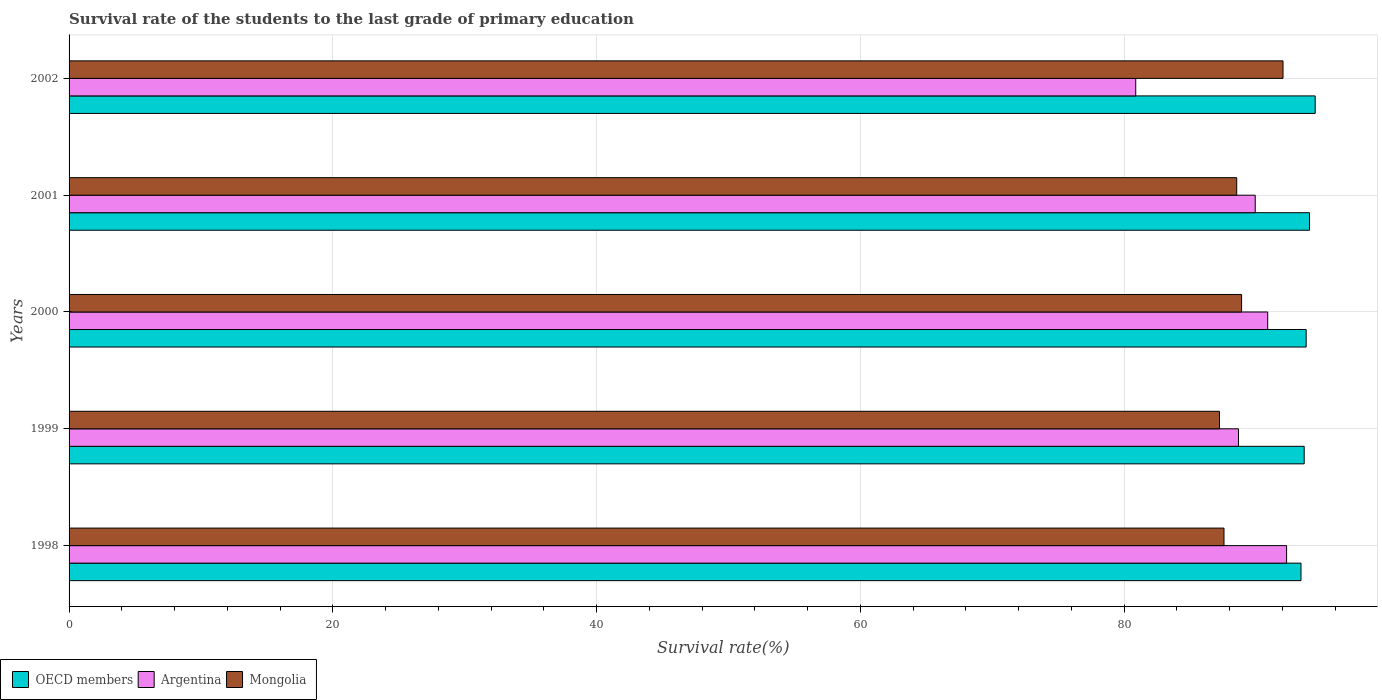Are the number of bars per tick equal to the number of legend labels?
Offer a very short reply. Yes. What is the label of the 3rd group of bars from the top?
Provide a short and direct response. 2000. What is the survival rate of the students in Mongolia in 2000?
Your answer should be very brief. 88.9. Across all years, what is the maximum survival rate of the students in Mongolia?
Offer a very short reply. 92.04. Across all years, what is the minimum survival rate of the students in Mongolia?
Your answer should be very brief. 87.22. What is the total survival rate of the students in Mongolia in the graph?
Offer a very short reply. 444.25. What is the difference between the survival rate of the students in Mongolia in 1998 and that in 2000?
Your response must be concise. -1.33. What is the difference between the survival rate of the students in Mongolia in 2000 and the survival rate of the students in Argentina in 2002?
Offer a terse response. 8.03. What is the average survival rate of the students in OECD members per year?
Your answer should be compact. 93.87. In the year 2001, what is the difference between the survival rate of the students in OECD members and survival rate of the students in Argentina?
Give a very brief answer. 4.12. What is the ratio of the survival rate of the students in Mongolia in 1998 to that in 2002?
Make the answer very short. 0.95. Is the survival rate of the students in Mongolia in 2000 less than that in 2001?
Keep it short and to the point. No. What is the difference between the highest and the second highest survival rate of the students in OECD members?
Provide a short and direct response. 0.43. What is the difference between the highest and the lowest survival rate of the students in Mongolia?
Your answer should be compact. 4.82. In how many years, is the survival rate of the students in Mongolia greater than the average survival rate of the students in Mongolia taken over all years?
Ensure brevity in your answer.  2. What does the 3rd bar from the top in 1998 represents?
Give a very brief answer. OECD members. What does the 3rd bar from the bottom in 1999 represents?
Your response must be concise. Mongolia. Is it the case that in every year, the sum of the survival rate of the students in Mongolia and survival rate of the students in Argentina is greater than the survival rate of the students in OECD members?
Your answer should be very brief. Yes. How many years are there in the graph?
Offer a very short reply. 5. What is the difference between two consecutive major ticks on the X-axis?
Keep it short and to the point. 20. Where does the legend appear in the graph?
Your answer should be compact. Bottom left. How many legend labels are there?
Provide a succinct answer. 3. How are the legend labels stacked?
Your answer should be very brief. Horizontal. What is the title of the graph?
Give a very brief answer. Survival rate of the students to the last grade of primary education. What is the label or title of the X-axis?
Make the answer very short. Survival rate(%). What is the Survival rate(%) in OECD members in 1998?
Give a very brief answer. 93.4. What is the Survival rate(%) in Argentina in 1998?
Ensure brevity in your answer.  92.31. What is the Survival rate(%) in Mongolia in 1998?
Offer a terse response. 87.56. What is the Survival rate(%) in OECD members in 1999?
Give a very brief answer. 93.64. What is the Survival rate(%) in Argentina in 1999?
Keep it short and to the point. 88.66. What is the Survival rate(%) of Mongolia in 1999?
Give a very brief answer. 87.22. What is the Survival rate(%) of OECD members in 2000?
Provide a succinct answer. 93.79. What is the Survival rate(%) of Argentina in 2000?
Offer a very short reply. 90.88. What is the Survival rate(%) of Mongolia in 2000?
Make the answer very short. 88.9. What is the Survival rate(%) in OECD members in 2001?
Give a very brief answer. 94.05. What is the Survival rate(%) in Argentina in 2001?
Offer a very short reply. 89.93. What is the Survival rate(%) in Mongolia in 2001?
Make the answer very short. 88.53. What is the Survival rate(%) in OECD members in 2002?
Make the answer very short. 94.48. What is the Survival rate(%) in Argentina in 2002?
Your answer should be very brief. 80.87. What is the Survival rate(%) in Mongolia in 2002?
Ensure brevity in your answer.  92.04. Across all years, what is the maximum Survival rate(%) in OECD members?
Your answer should be very brief. 94.48. Across all years, what is the maximum Survival rate(%) in Argentina?
Offer a terse response. 92.31. Across all years, what is the maximum Survival rate(%) of Mongolia?
Your response must be concise. 92.04. Across all years, what is the minimum Survival rate(%) of OECD members?
Your answer should be compact. 93.4. Across all years, what is the minimum Survival rate(%) in Argentina?
Give a very brief answer. 80.87. Across all years, what is the minimum Survival rate(%) of Mongolia?
Offer a terse response. 87.22. What is the total Survival rate(%) of OECD members in the graph?
Your response must be concise. 469.37. What is the total Survival rate(%) of Argentina in the graph?
Your response must be concise. 442.66. What is the total Survival rate(%) of Mongolia in the graph?
Offer a very short reply. 444.25. What is the difference between the Survival rate(%) in OECD members in 1998 and that in 1999?
Provide a short and direct response. -0.24. What is the difference between the Survival rate(%) of Argentina in 1998 and that in 1999?
Your answer should be very brief. 3.65. What is the difference between the Survival rate(%) of Mongolia in 1998 and that in 1999?
Your answer should be very brief. 0.34. What is the difference between the Survival rate(%) of OECD members in 1998 and that in 2000?
Your response must be concise. -0.39. What is the difference between the Survival rate(%) in Argentina in 1998 and that in 2000?
Ensure brevity in your answer.  1.43. What is the difference between the Survival rate(%) of Mongolia in 1998 and that in 2000?
Give a very brief answer. -1.33. What is the difference between the Survival rate(%) in OECD members in 1998 and that in 2001?
Provide a succinct answer. -0.65. What is the difference between the Survival rate(%) in Argentina in 1998 and that in 2001?
Offer a very short reply. 2.38. What is the difference between the Survival rate(%) of Mongolia in 1998 and that in 2001?
Provide a succinct answer. -0.96. What is the difference between the Survival rate(%) of OECD members in 1998 and that in 2002?
Offer a terse response. -1.08. What is the difference between the Survival rate(%) in Argentina in 1998 and that in 2002?
Your response must be concise. 11.44. What is the difference between the Survival rate(%) in Mongolia in 1998 and that in 2002?
Ensure brevity in your answer.  -4.47. What is the difference between the Survival rate(%) in OECD members in 1999 and that in 2000?
Offer a terse response. -0.15. What is the difference between the Survival rate(%) in Argentina in 1999 and that in 2000?
Ensure brevity in your answer.  -2.21. What is the difference between the Survival rate(%) of Mongolia in 1999 and that in 2000?
Provide a short and direct response. -1.68. What is the difference between the Survival rate(%) in OECD members in 1999 and that in 2001?
Offer a terse response. -0.4. What is the difference between the Survival rate(%) in Argentina in 1999 and that in 2001?
Give a very brief answer. -1.27. What is the difference between the Survival rate(%) of Mongolia in 1999 and that in 2001?
Offer a terse response. -1.31. What is the difference between the Survival rate(%) in OECD members in 1999 and that in 2002?
Your answer should be compact. -0.83. What is the difference between the Survival rate(%) in Argentina in 1999 and that in 2002?
Ensure brevity in your answer.  7.79. What is the difference between the Survival rate(%) in Mongolia in 1999 and that in 2002?
Your answer should be compact. -4.82. What is the difference between the Survival rate(%) of OECD members in 2000 and that in 2001?
Your answer should be very brief. -0.25. What is the difference between the Survival rate(%) in Argentina in 2000 and that in 2001?
Provide a short and direct response. 0.95. What is the difference between the Survival rate(%) in Mongolia in 2000 and that in 2001?
Give a very brief answer. 0.37. What is the difference between the Survival rate(%) of OECD members in 2000 and that in 2002?
Your response must be concise. -0.68. What is the difference between the Survival rate(%) of Argentina in 2000 and that in 2002?
Your answer should be very brief. 10.01. What is the difference between the Survival rate(%) of Mongolia in 2000 and that in 2002?
Your response must be concise. -3.14. What is the difference between the Survival rate(%) of OECD members in 2001 and that in 2002?
Ensure brevity in your answer.  -0.43. What is the difference between the Survival rate(%) in Argentina in 2001 and that in 2002?
Provide a short and direct response. 9.06. What is the difference between the Survival rate(%) in Mongolia in 2001 and that in 2002?
Your response must be concise. -3.51. What is the difference between the Survival rate(%) in OECD members in 1998 and the Survival rate(%) in Argentina in 1999?
Keep it short and to the point. 4.74. What is the difference between the Survival rate(%) in OECD members in 1998 and the Survival rate(%) in Mongolia in 1999?
Offer a terse response. 6.18. What is the difference between the Survival rate(%) in Argentina in 1998 and the Survival rate(%) in Mongolia in 1999?
Make the answer very short. 5.09. What is the difference between the Survival rate(%) of OECD members in 1998 and the Survival rate(%) of Argentina in 2000?
Your answer should be very brief. 2.52. What is the difference between the Survival rate(%) of OECD members in 1998 and the Survival rate(%) of Mongolia in 2000?
Provide a succinct answer. 4.5. What is the difference between the Survival rate(%) of Argentina in 1998 and the Survival rate(%) of Mongolia in 2000?
Offer a very short reply. 3.41. What is the difference between the Survival rate(%) in OECD members in 1998 and the Survival rate(%) in Argentina in 2001?
Make the answer very short. 3.47. What is the difference between the Survival rate(%) of OECD members in 1998 and the Survival rate(%) of Mongolia in 2001?
Ensure brevity in your answer.  4.87. What is the difference between the Survival rate(%) of Argentina in 1998 and the Survival rate(%) of Mongolia in 2001?
Provide a short and direct response. 3.78. What is the difference between the Survival rate(%) of OECD members in 1998 and the Survival rate(%) of Argentina in 2002?
Your response must be concise. 12.53. What is the difference between the Survival rate(%) of OECD members in 1998 and the Survival rate(%) of Mongolia in 2002?
Offer a terse response. 1.36. What is the difference between the Survival rate(%) in Argentina in 1998 and the Survival rate(%) in Mongolia in 2002?
Provide a succinct answer. 0.27. What is the difference between the Survival rate(%) of OECD members in 1999 and the Survival rate(%) of Argentina in 2000?
Provide a short and direct response. 2.77. What is the difference between the Survival rate(%) of OECD members in 1999 and the Survival rate(%) of Mongolia in 2000?
Keep it short and to the point. 4.75. What is the difference between the Survival rate(%) of Argentina in 1999 and the Survival rate(%) of Mongolia in 2000?
Provide a short and direct response. -0.23. What is the difference between the Survival rate(%) of OECD members in 1999 and the Survival rate(%) of Argentina in 2001?
Your response must be concise. 3.71. What is the difference between the Survival rate(%) in OECD members in 1999 and the Survival rate(%) in Mongolia in 2001?
Give a very brief answer. 5.12. What is the difference between the Survival rate(%) of Argentina in 1999 and the Survival rate(%) of Mongolia in 2001?
Provide a short and direct response. 0.14. What is the difference between the Survival rate(%) in OECD members in 1999 and the Survival rate(%) in Argentina in 2002?
Ensure brevity in your answer.  12.77. What is the difference between the Survival rate(%) in OECD members in 1999 and the Survival rate(%) in Mongolia in 2002?
Make the answer very short. 1.61. What is the difference between the Survival rate(%) in Argentina in 1999 and the Survival rate(%) in Mongolia in 2002?
Make the answer very short. -3.37. What is the difference between the Survival rate(%) in OECD members in 2000 and the Survival rate(%) in Argentina in 2001?
Keep it short and to the point. 3.86. What is the difference between the Survival rate(%) in OECD members in 2000 and the Survival rate(%) in Mongolia in 2001?
Make the answer very short. 5.27. What is the difference between the Survival rate(%) of Argentina in 2000 and the Survival rate(%) of Mongolia in 2001?
Give a very brief answer. 2.35. What is the difference between the Survival rate(%) of OECD members in 2000 and the Survival rate(%) of Argentina in 2002?
Give a very brief answer. 12.92. What is the difference between the Survival rate(%) of OECD members in 2000 and the Survival rate(%) of Mongolia in 2002?
Give a very brief answer. 1.76. What is the difference between the Survival rate(%) of Argentina in 2000 and the Survival rate(%) of Mongolia in 2002?
Your answer should be very brief. -1.16. What is the difference between the Survival rate(%) of OECD members in 2001 and the Survival rate(%) of Argentina in 2002?
Ensure brevity in your answer.  13.18. What is the difference between the Survival rate(%) in OECD members in 2001 and the Survival rate(%) in Mongolia in 2002?
Give a very brief answer. 2.01. What is the difference between the Survival rate(%) of Argentina in 2001 and the Survival rate(%) of Mongolia in 2002?
Your answer should be compact. -2.11. What is the average Survival rate(%) of OECD members per year?
Keep it short and to the point. 93.87. What is the average Survival rate(%) in Argentina per year?
Give a very brief answer. 88.53. What is the average Survival rate(%) of Mongolia per year?
Keep it short and to the point. 88.85. In the year 1998, what is the difference between the Survival rate(%) in OECD members and Survival rate(%) in Argentina?
Your answer should be compact. 1.09. In the year 1998, what is the difference between the Survival rate(%) in OECD members and Survival rate(%) in Mongolia?
Ensure brevity in your answer.  5.84. In the year 1998, what is the difference between the Survival rate(%) in Argentina and Survival rate(%) in Mongolia?
Your response must be concise. 4.75. In the year 1999, what is the difference between the Survival rate(%) in OECD members and Survival rate(%) in Argentina?
Make the answer very short. 4.98. In the year 1999, what is the difference between the Survival rate(%) of OECD members and Survival rate(%) of Mongolia?
Ensure brevity in your answer.  6.42. In the year 1999, what is the difference between the Survival rate(%) of Argentina and Survival rate(%) of Mongolia?
Provide a succinct answer. 1.44. In the year 2000, what is the difference between the Survival rate(%) of OECD members and Survival rate(%) of Argentina?
Provide a succinct answer. 2.92. In the year 2000, what is the difference between the Survival rate(%) of OECD members and Survival rate(%) of Mongolia?
Keep it short and to the point. 4.9. In the year 2000, what is the difference between the Survival rate(%) in Argentina and Survival rate(%) in Mongolia?
Offer a terse response. 1.98. In the year 2001, what is the difference between the Survival rate(%) in OECD members and Survival rate(%) in Argentina?
Offer a very short reply. 4.12. In the year 2001, what is the difference between the Survival rate(%) in OECD members and Survival rate(%) in Mongolia?
Provide a succinct answer. 5.52. In the year 2001, what is the difference between the Survival rate(%) in Argentina and Survival rate(%) in Mongolia?
Your answer should be very brief. 1.4. In the year 2002, what is the difference between the Survival rate(%) in OECD members and Survival rate(%) in Argentina?
Your answer should be very brief. 13.61. In the year 2002, what is the difference between the Survival rate(%) in OECD members and Survival rate(%) in Mongolia?
Ensure brevity in your answer.  2.44. In the year 2002, what is the difference between the Survival rate(%) of Argentina and Survival rate(%) of Mongolia?
Provide a succinct answer. -11.17. What is the ratio of the Survival rate(%) of Argentina in 1998 to that in 1999?
Your response must be concise. 1.04. What is the ratio of the Survival rate(%) in OECD members in 1998 to that in 2000?
Ensure brevity in your answer.  1. What is the ratio of the Survival rate(%) of Argentina in 1998 to that in 2000?
Your answer should be compact. 1.02. What is the ratio of the Survival rate(%) in Argentina in 1998 to that in 2001?
Give a very brief answer. 1.03. What is the ratio of the Survival rate(%) in OECD members in 1998 to that in 2002?
Your answer should be very brief. 0.99. What is the ratio of the Survival rate(%) of Argentina in 1998 to that in 2002?
Keep it short and to the point. 1.14. What is the ratio of the Survival rate(%) in Mongolia in 1998 to that in 2002?
Your answer should be compact. 0.95. What is the ratio of the Survival rate(%) of OECD members in 1999 to that in 2000?
Provide a short and direct response. 1. What is the ratio of the Survival rate(%) of Argentina in 1999 to that in 2000?
Make the answer very short. 0.98. What is the ratio of the Survival rate(%) of Mongolia in 1999 to that in 2000?
Your answer should be very brief. 0.98. What is the ratio of the Survival rate(%) of OECD members in 1999 to that in 2001?
Provide a short and direct response. 1. What is the ratio of the Survival rate(%) in Argentina in 1999 to that in 2001?
Give a very brief answer. 0.99. What is the ratio of the Survival rate(%) in Mongolia in 1999 to that in 2001?
Offer a very short reply. 0.99. What is the ratio of the Survival rate(%) of OECD members in 1999 to that in 2002?
Provide a succinct answer. 0.99. What is the ratio of the Survival rate(%) in Argentina in 1999 to that in 2002?
Provide a short and direct response. 1.1. What is the ratio of the Survival rate(%) of Mongolia in 1999 to that in 2002?
Provide a succinct answer. 0.95. What is the ratio of the Survival rate(%) in Argentina in 2000 to that in 2001?
Provide a succinct answer. 1.01. What is the ratio of the Survival rate(%) in Argentina in 2000 to that in 2002?
Offer a terse response. 1.12. What is the ratio of the Survival rate(%) of Mongolia in 2000 to that in 2002?
Your answer should be compact. 0.97. What is the ratio of the Survival rate(%) of OECD members in 2001 to that in 2002?
Your response must be concise. 1. What is the ratio of the Survival rate(%) in Argentina in 2001 to that in 2002?
Ensure brevity in your answer.  1.11. What is the ratio of the Survival rate(%) in Mongolia in 2001 to that in 2002?
Provide a short and direct response. 0.96. What is the difference between the highest and the second highest Survival rate(%) of OECD members?
Provide a succinct answer. 0.43. What is the difference between the highest and the second highest Survival rate(%) of Argentina?
Ensure brevity in your answer.  1.43. What is the difference between the highest and the second highest Survival rate(%) in Mongolia?
Offer a terse response. 3.14. What is the difference between the highest and the lowest Survival rate(%) of OECD members?
Provide a short and direct response. 1.08. What is the difference between the highest and the lowest Survival rate(%) in Argentina?
Offer a terse response. 11.44. What is the difference between the highest and the lowest Survival rate(%) in Mongolia?
Offer a very short reply. 4.82. 